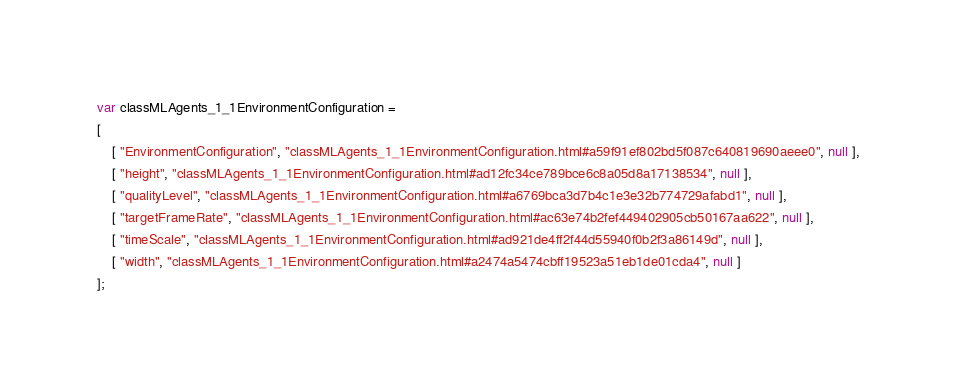Convert code to text. <code><loc_0><loc_0><loc_500><loc_500><_JavaScript_>var classMLAgents_1_1EnvironmentConfiguration =
[
    [ "EnvironmentConfiguration", "classMLAgents_1_1EnvironmentConfiguration.html#a59f91ef802bd5f087c640819690aeee0", null ],
    [ "height", "classMLAgents_1_1EnvironmentConfiguration.html#ad12fc34ce789bce6c8a05d8a17138534", null ],
    [ "qualityLevel", "classMLAgents_1_1EnvironmentConfiguration.html#a6769bca3d7b4c1e3e32b774729afabd1", null ],
    [ "targetFrameRate", "classMLAgents_1_1EnvironmentConfiguration.html#ac63e74b2fef449402905cb50167aa622", null ],
    [ "timeScale", "classMLAgents_1_1EnvironmentConfiguration.html#ad921de4ff2f44d55940f0b2f3a86149d", null ],
    [ "width", "classMLAgents_1_1EnvironmentConfiguration.html#a2474a5474cbff19523a51eb1de01cda4", null ]
];</code> 